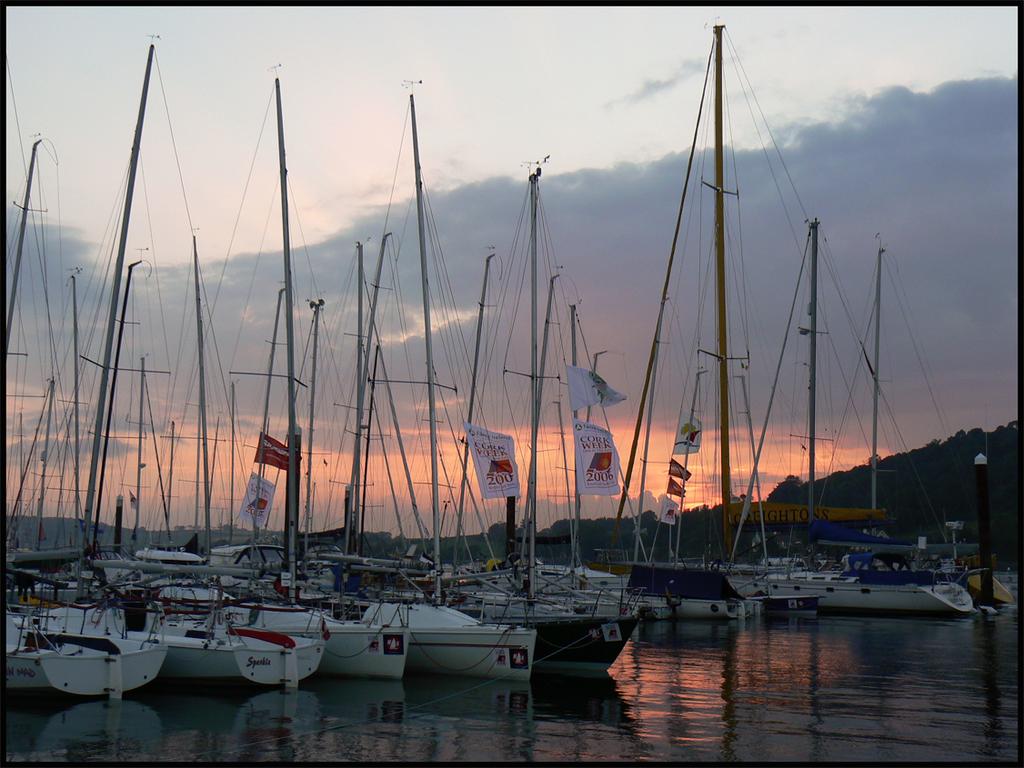What week are they celebrating?
Provide a succinct answer. Cork week. What colour is the first boat from left?
Make the answer very short. White. 